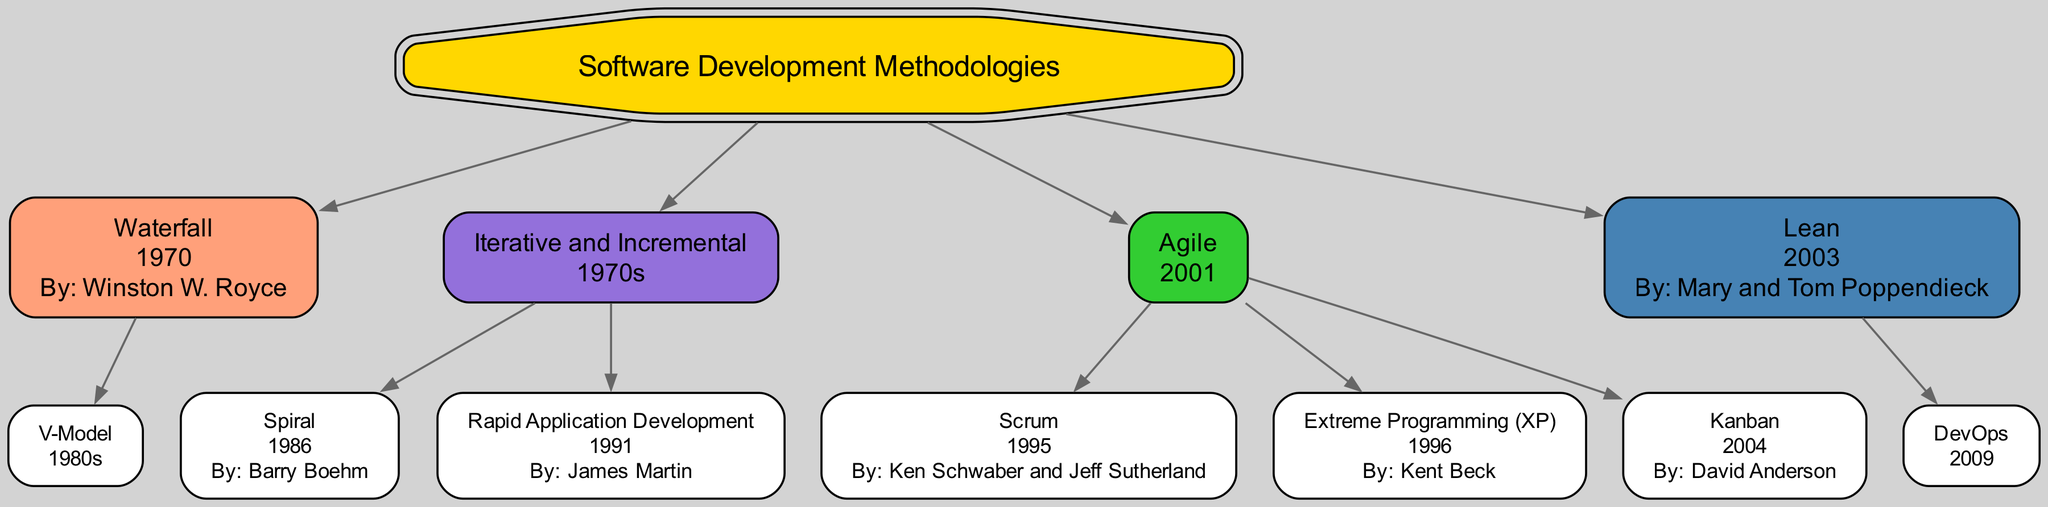What is the root of the family tree? The root node is labeled "Software Development Methodologies," which represents the main subject of the diagram. It is the first and foundational point that connects all other methodologies.
Answer: Software Development Methodologies Who created the Waterfall methodology? In the diagram, under the Waterfall node, it states "By: Winston W. Royce," indicating that he is the creator of this specific methodology.
Answer: Winston W. Royce What year was Agile introduced? The Agile methodology node has the year "2001" written next to it, reflecting the year it was established as per the information in the diagram.
Answer: 2001 How many children does the Iterative and Incremental methodology have? The Iterative and Incremental node lists two children, namely "Spiral" and "Rapid Application Development." Counting these nodes gives the total number of child methodologies.
Answer: 2 What methodology is a child of Lean? Under the Lean node, it mentions "DevOps" as the child, demonstrating that this methodology directly descends from Lean in the family tree.
Answer: DevOps Which methodology has Ken Schwaber and Jeff Sutherland as creators? Within the Agile section of the diagram, the Scrum methodology is specified as having both Ken Schwaber and Jeff Sutherland listed as creators, indicating their contribution to this approach.
Answer: Scrum What color represents Agile methodologies? In the diagram, Agile methodologies are indicated with the color light green, which appears on the nodes related to Agile methodologies like Scrum and Kanban.
Answer: Light green Which methodology was first introduced: V-Model or Extreme Programming? By examining the years associated with V-Model (1980s) and Extreme Programming (1996), it is clear that the V-Model has an earlier year, marking it as the first of the two methodologies to be introduced.
Answer: V-Model How many methodologies were created before 2000? The diagram shows the following methodologies with their years: Waterfall (1970), Iterative and Incremental (1970s), Spiral (1986), Rapid Application Development (1991), Scrum (1995), and Extreme Programming (1996), totaling six methodologies before 2000.
Answer: 6 